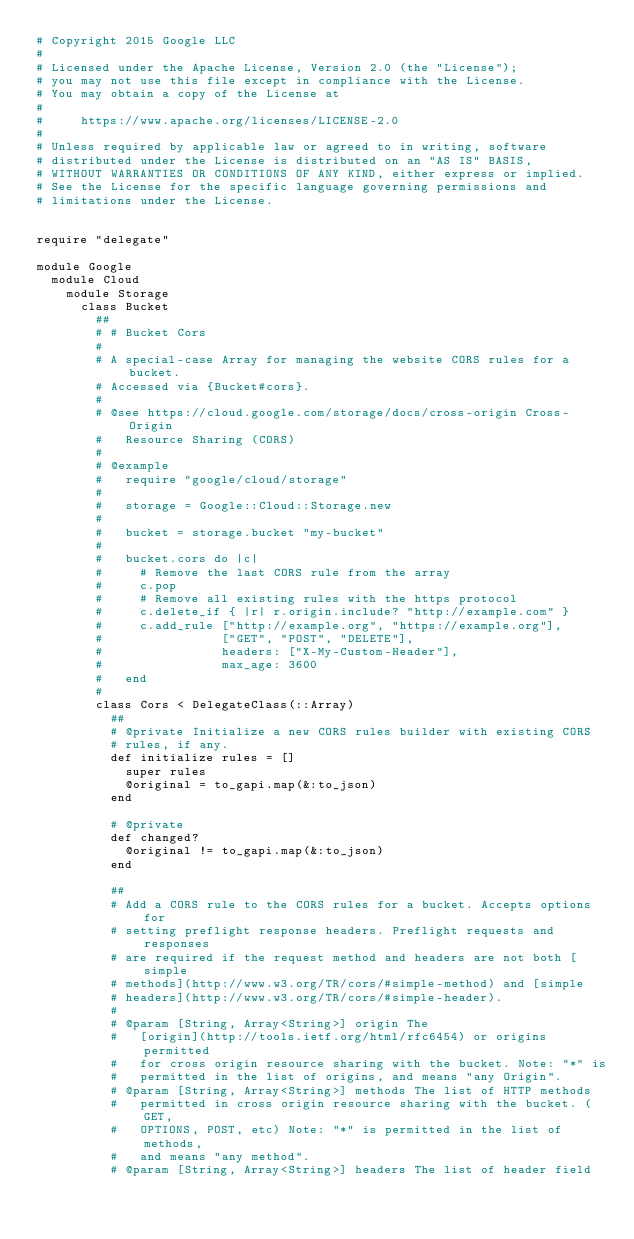<code> <loc_0><loc_0><loc_500><loc_500><_Ruby_># Copyright 2015 Google LLC
#
# Licensed under the Apache License, Version 2.0 (the "License");
# you may not use this file except in compliance with the License.
# You may obtain a copy of the License at
#
#     https://www.apache.org/licenses/LICENSE-2.0
#
# Unless required by applicable law or agreed to in writing, software
# distributed under the License is distributed on an "AS IS" BASIS,
# WITHOUT WARRANTIES OR CONDITIONS OF ANY KIND, either express or implied.
# See the License for the specific language governing permissions and
# limitations under the License.


require "delegate"

module Google
  module Cloud
    module Storage
      class Bucket
        ##
        # # Bucket Cors
        #
        # A special-case Array for managing the website CORS rules for a bucket.
        # Accessed via {Bucket#cors}.
        #
        # @see https://cloud.google.com/storage/docs/cross-origin Cross-Origin
        #   Resource Sharing (CORS)
        #
        # @example
        #   require "google/cloud/storage"
        #
        #   storage = Google::Cloud::Storage.new
        #
        #   bucket = storage.bucket "my-bucket"
        #
        #   bucket.cors do |c|
        #     # Remove the last CORS rule from the array
        #     c.pop
        #     # Remove all existing rules with the https protocol
        #     c.delete_if { |r| r.origin.include? "http://example.com" }
        #     c.add_rule ["http://example.org", "https://example.org"],
        #                ["GET", "POST", "DELETE"],
        #                headers: ["X-My-Custom-Header"],
        #                max_age: 3600
        #   end
        #
        class Cors < DelegateClass(::Array)
          ##
          # @private Initialize a new CORS rules builder with existing CORS
          # rules, if any.
          def initialize rules = []
            super rules
            @original = to_gapi.map(&:to_json)
          end

          # @private
          def changed?
            @original != to_gapi.map(&:to_json)
          end

          ##
          # Add a CORS rule to the CORS rules for a bucket. Accepts options for
          # setting preflight response headers. Preflight requests and responses
          # are required if the request method and headers are not both [simple
          # methods](http://www.w3.org/TR/cors/#simple-method) and [simple
          # headers](http://www.w3.org/TR/cors/#simple-header).
          #
          # @param [String, Array<String>] origin The
          #   [origin](http://tools.ietf.org/html/rfc6454) or origins permitted
          #   for cross origin resource sharing with the bucket. Note: "*" is
          #   permitted in the list of origins, and means "any Origin".
          # @param [String, Array<String>] methods The list of HTTP methods
          #   permitted in cross origin resource sharing with the bucket. (GET,
          #   OPTIONS, POST, etc) Note: "*" is permitted in the list of methods,
          #   and means "any method".
          # @param [String, Array<String>] headers The list of header field</code> 